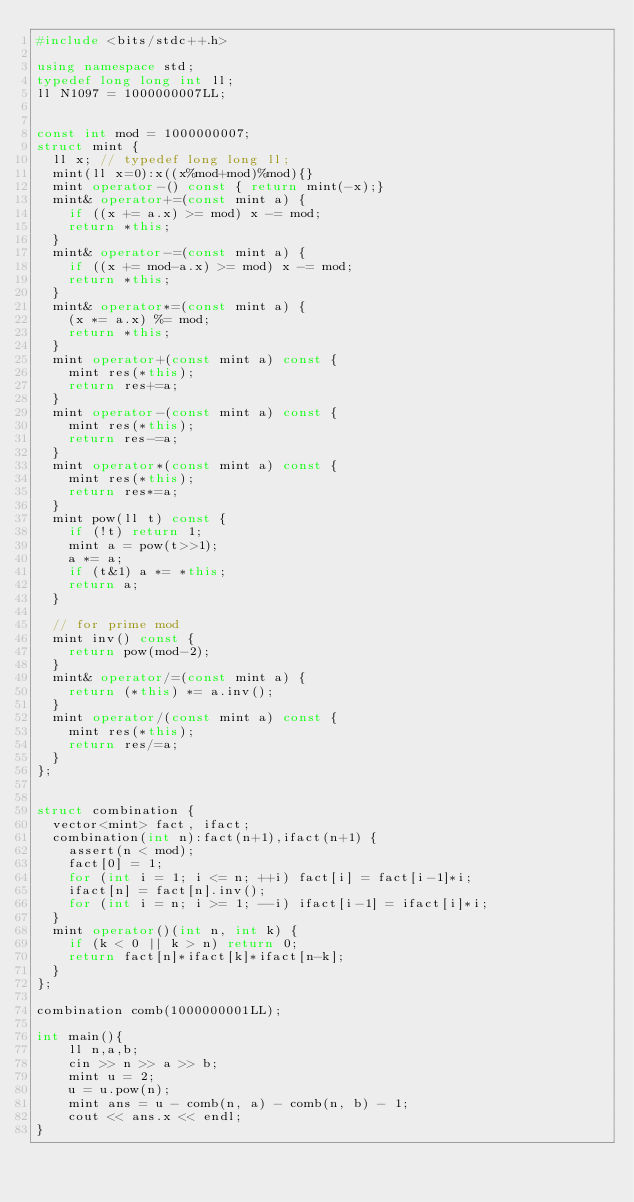Convert code to text. <code><loc_0><loc_0><loc_500><loc_500><_C++_>#include <bits/stdc++.h>

using namespace std;
typedef long long int ll;
ll N1097 = 1000000007LL;


const int mod = 1000000007;
struct mint {
  ll x; // typedef long long ll;
  mint(ll x=0):x((x%mod+mod)%mod){}
  mint operator-() const { return mint(-x);}
  mint& operator+=(const mint a) {
    if ((x += a.x) >= mod) x -= mod;
    return *this;
  }
  mint& operator-=(const mint a) {
    if ((x += mod-a.x) >= mod) x -= mod;
    return *this;
  }
  mint& operator*=(const mint a) {
    (x *= a.x) %= mod;
    return *this;
  }
  mint operator+(const mint a) const {
    mint res(*this);
    return res+=a;
  }
  mint operator-(const mint a) const {
    mint res(*this);
    return res-=a;
  }
  mint operator*(const mint a) const {
    mint res(*this);
    return res*=a;
  }
  mint pow(ll t) const {
    if (!t) return 1;
    mint a = pow(t>>1);
    a *= a;
    if (t&1) a *= *this;
    return a;
  }

  // for prime mod
  mint inv() const {
    return pow(mod-2);
  }
  mint& operator/=(const mint a) {
    return (*this) *= a.inv();
  }
  mint operator/(const mint a) const {
    mint res(*this);
    return res/=a;
  }
};


struct combination {
  vector<mint> fact, ifact;
  combination(int n):fact(n+1),ifact(n+1) {
    assert(n < mod);
    fact[0] = 1;
    for (int i = 1; i <= n; ++i) fact[i] = fact[i-1]*i;
    ifact[n] = fact[n].inv();
    for (int i = n; i >= 1; --i) ifact[i-1] = ifact[i]*i;
  }
  mint operator()(int n, int k) {
    if (k < 0 || k > n) return 0;
    return fact[n]*ifact[k]*ifact[n-k];
  }
};

combination comb(1000000001LL);

int main(){
    ll n,a,b;
    cin >> n >> a >> b;
    mint u = 2;
    u = u.pow(n);
    mint ans = u - comb(n, a) - comb(n, b) - 1;
    cout << ans.x << endl;
}


</code> 